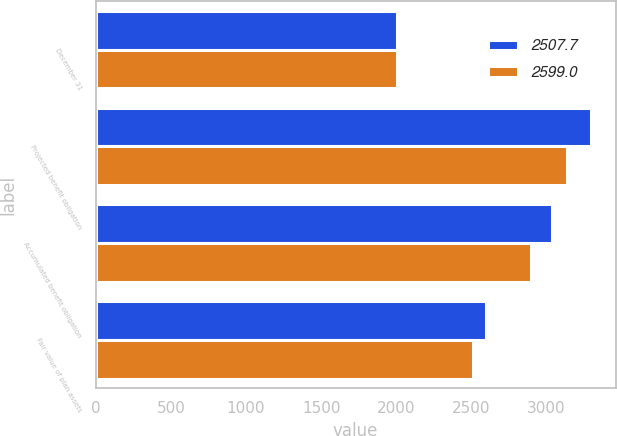<chart> <loc_0><loc_0><loc_500><loc_500><stacked_bar_chart><ecel><fcel>December 31<fcel>Projected benefit obligation<fcel>Accumulated benefit obligation<fcel>Fair value of plan assets<nl><fcel>2507.7<fcel>2005<fcel>3294.4<fcel>3038.4<fcel>2599<nl><fcel>2599<fcel>2004<fcel>3135.5<fcel>2898.2<fcel>2507.7<nl></chart> 